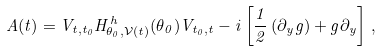<formula> <loc_0><loc_0><loc_500><loc_500>A ( t ) = V _ { t , t _ { 0 } } H _ { \theta _ { 0 } , \mathcal { V } ( t ) } ^ { h } ( \theta _ { 0 } ) V _ { t _ { 0 } , t } - i \left [ \frac { 1 } { 2 } \left ( \partial _ { y } g \right ) + g \partial _ { y } \right ] \, ,</formula> 